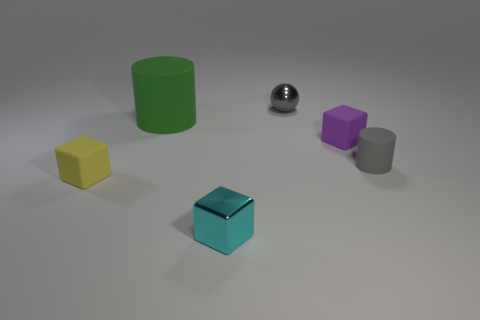Add 3 yellow matte objects. How many objects exist? 9 Subtract all spheres. How many objects are left? 5 Add 5 tiny shiny spheres. How many tiny shiny spheres exist? 6 Subtract 1 cyan blocks. How many objects are left? 5 Subtract all big blue balls. Subtract all gray rubber cylinders. How many objects are left? 5 Add 5 green matte things. How many green matte things are left? 6 